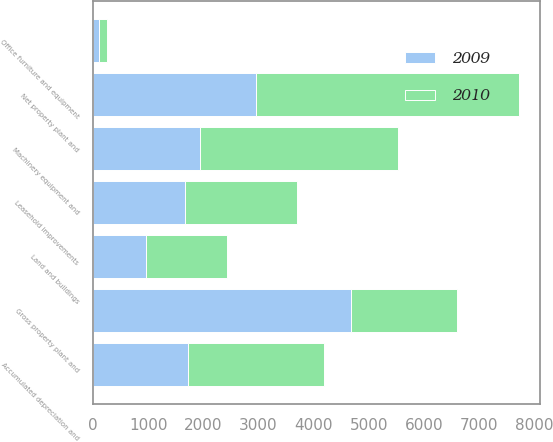Convert chart. <chart><loc_0><loc_0><loc_500><loc_500><stacked_bar_chart><ecel><fcel>Land and buildings<fcel>Machinery equipment and<fcel>Office furniture and equipment<fcel>Leasehold improvements<fcel>Gross property plant and<fcel>Accumulated depreciation and<fcel>Net property plant and<nl><fcel>2010<fcel>1471<fcel>3589<fcel>144<fcel>2030<fcel>1932<fcel>2466<fcel>4768<nl><fcel>2009<fcel>955<fcel>1932<fcel>115<fcel>1665<fcel>4667<fcel>1713<fcel>2954<nl></chart> 